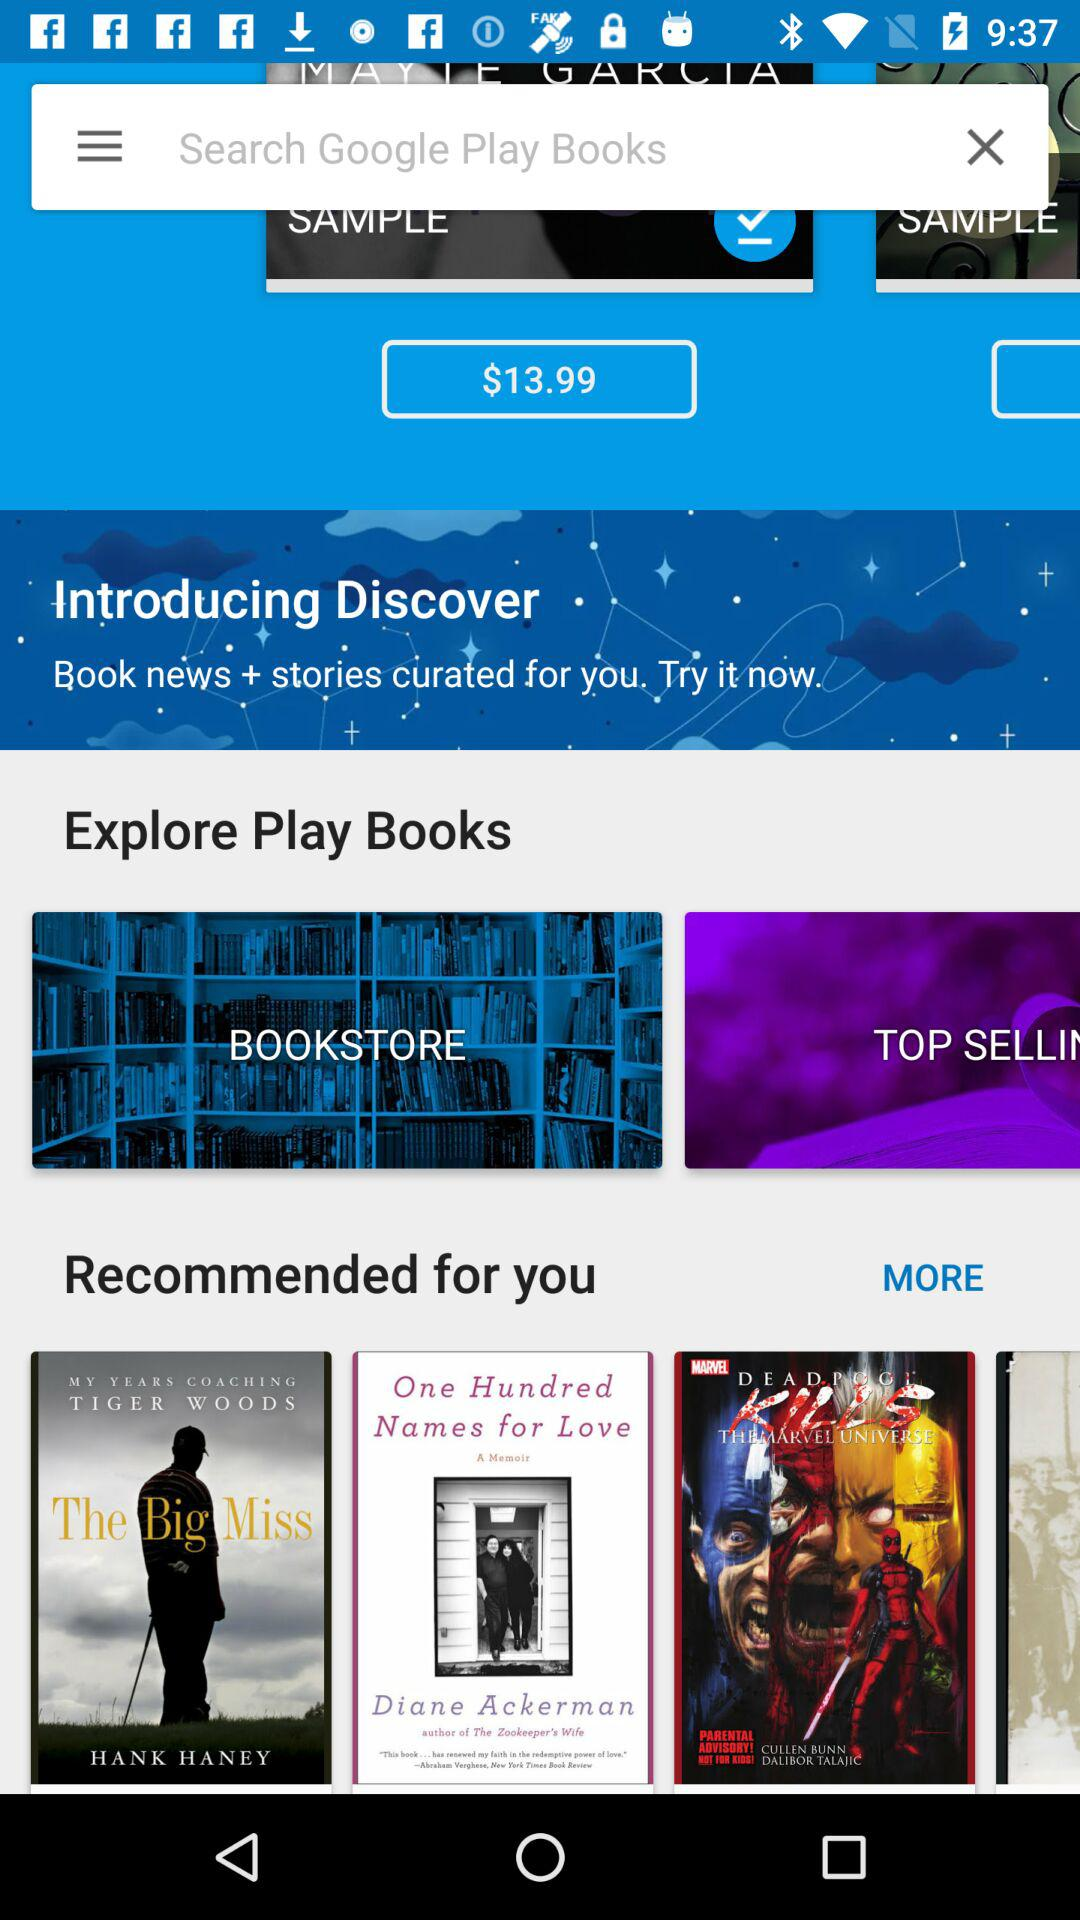What is the booking amount? The booking amount is $13.99. 